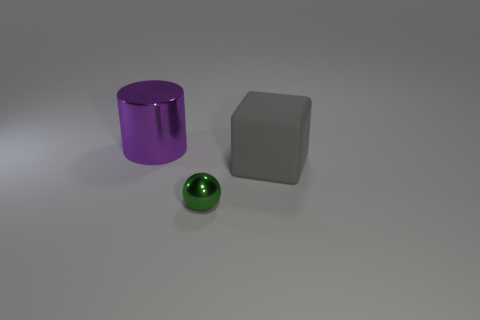Add 1 spheres. How many objects exist? 4 Subtract 0 red cylinders. How many objects are left? 3 Subtract all cylinders. How many objects are left? 2 Subtract all gray matte cylinders. Subtract all blocks. How many objects are left? 2 Add 1 big rubber cubes. How many big rubber cubes are left? 2 Add 2 tiny things. How many tiny things exist? 3 